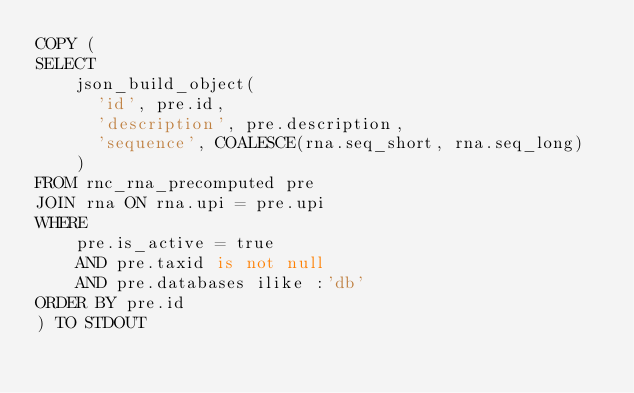<code> <loc_0><loc_0><loc_500><loc_500><_SQL_>COPY (
SELECT
    json_build_object(
      'id', pre.id,
      'description', pre.description,
      'sequence', COALESCE(rna.seq_short, rna.seq_long)
    )
FROM rnc_rna_precomputed pre
JOIN rna ON rna.upi = pre.upi
WHERE
    pre.is_active = true
    AND pre.taxid is not null
    AND pre.databases ilike :'db'
ORDER BY pre.id
) TO STDOUT
</code> 